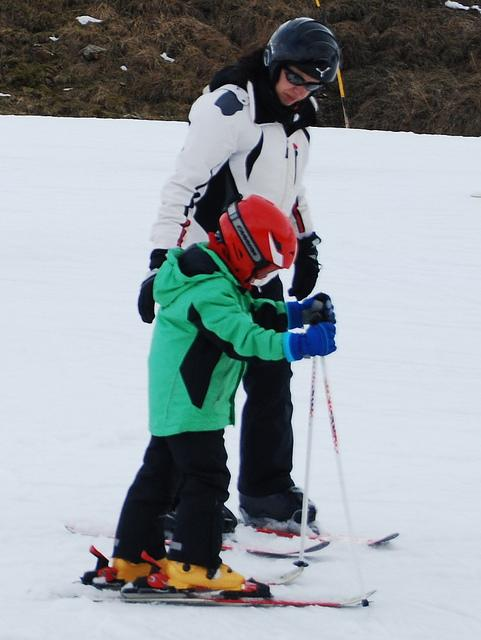Why are his skis so small?

Choices:
A) are broken
B) is new
C) is child
D) someone else's is child 